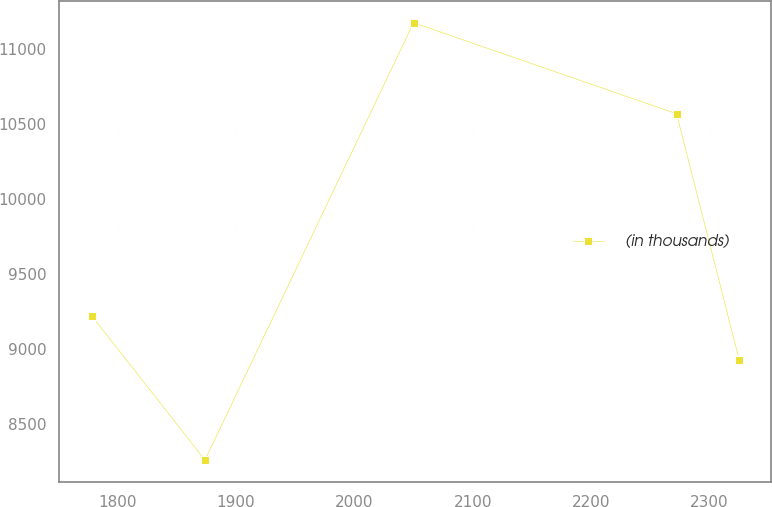<chart> <loc_0><loc_0><loc_500><loc_500><line_chart><ecel><fcel>(in thousands)<nl><fcel>1778.2<fcel>9220.49<nl><fcel>1873.87<fcel>8257.5<nl><fcel>2049.96<fcel>11176.8<nl><fcel>2272.09<fcel>10568.8<nl><fcel>2324.92<fcel>8928.56<nl></chart> 